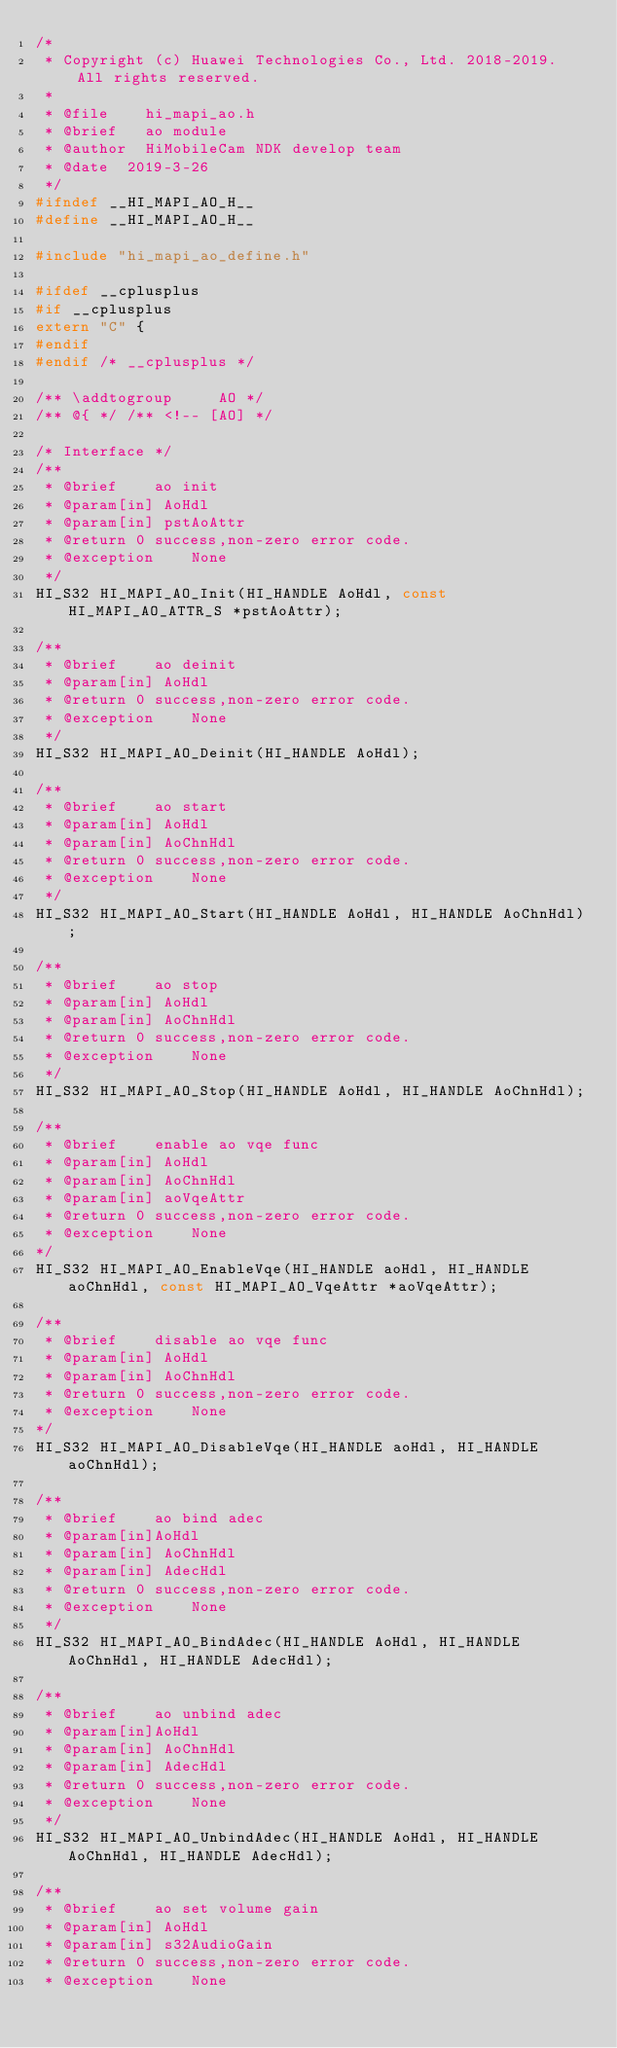Convert code to text. <code><loc_0><loc_0><loc_500><loc_500><_C_>/*
 * Copyright (c) Huawei Technologies Co., Ltd. 2018-2019. All rights reserved.
 *
 * @file    hi_mapi_ao.h
 * @brief   ao module
 * @author  HiMobileCam NDK develop team
 * @date  2019-3-26
 */
#ifndef __HI_MAPI_AO_H__
#define __HI_MAPI_AO_H__

#include "hi_mapi_ao_define.h"

#ifdef __cplusplus
#if __cplusplus
extern "C" {
#endif
#endif /* __cplusplus */

/** \addtogroup     AO */
/** @{ */ /** <!-- [AO] */

/* Interface */
/**
 * @brief    ao init
 * @param[in] AoHdl
 * @param[in] pstAoAttr
 * @return 0 success,non-zero error code.
 * @exception    None
 */
HI_S32 HI_MAPI_AO_Init(HI_HANDLE AoHdl, const HI_MAPI_AO_ATTR_S *pstAoAttr);

/**
 * @brief    ao deinit
 * @param[in] AoHdl
 * @return 0 success,non-zero error code.
 * @exception    None
 */
HI_S32 HI_MAPI_AO_Deinit(HI_HANDLE AoHdl);

/**
 * @brief    ao start
 * @param[in] AoHdl
 * @param[in] AoChnHdl
 * @return 0 success,non-zero error code.
 * @exception    None
 */
HI_S32 HI_MAPI_AO_Start(HI_HANDLE AoHdl, HI_HANDLE AoChnHdl);

/**
 * @brief    ao stop
 * @param[in] AoHdl
 * @param[in] AoChnHdl
 * @return 0 success,non-zero error code.
 * @exception    None
 */
HI_S32 HI_MAPI_AO_Stop(HI_HANDLE AoHdl, HI_HANDLE AoChnHdl);

/**
 * @brief    enable ao vqe func
 * @param[in] AoHdl
 * @param[in] AoChnHdl
 * @param[in] aoVqeAttr
 * @return 0 success,non-zero error code.
 * @exception    None
*/
HI_S32 HI_MAPI_AO_EnableVqe(HI_HANDLE aoHdl, HI_HANDLE aoChnHdl, const HI_MAPI_AO_VqeAttr *aoVqeAttr);

/**
 * @brief    disable ao vqe func
 * @param[in] AoHdl
 * @param[in] AoChnHdl
 * @return 0 success,non-zero error code.
 * @exception    None
*/
HI_S32 HI_MAPI_AO_DisableVqe(HI_HANDLE aoHdl, HI_HANDLE aoChnHdl);

/**
 * @brief    ao bind adec
 * @param[in]AoHdl
 * @param[in] AoChnHdl
 * @param[in] AdecHdl
 * @return 0 success,non-zero error code.
 * @exception    None
 */
HI_S32 HI_MAPI_AO_BindAdec(HI_HANDLE AoHdl, HI_HANDLE AoChnHdl, HI_HANDLE AdecHdl);

/**
 * @brief    ao unbind adec
 * @param[in]AoHdl
 * @param[in] AoChnHdl
 * @param[in] AdecHdl
 * @return 0 success,non-zero error code.
 * @exception    None
 */
HI_S32 HI_MAPI_AO_UnbindAdec(HI_HANDLE AoHdl, HI_HANDLE AoChnHdl, HI_HANDLE AdecHdl);

/**
 * @brief    ao set volume gain
 * @param[in] AoHdl
 * @param[in] s32AudioGain
 * @return 0 success,non-zero error code.
 * @exception    None</code> 